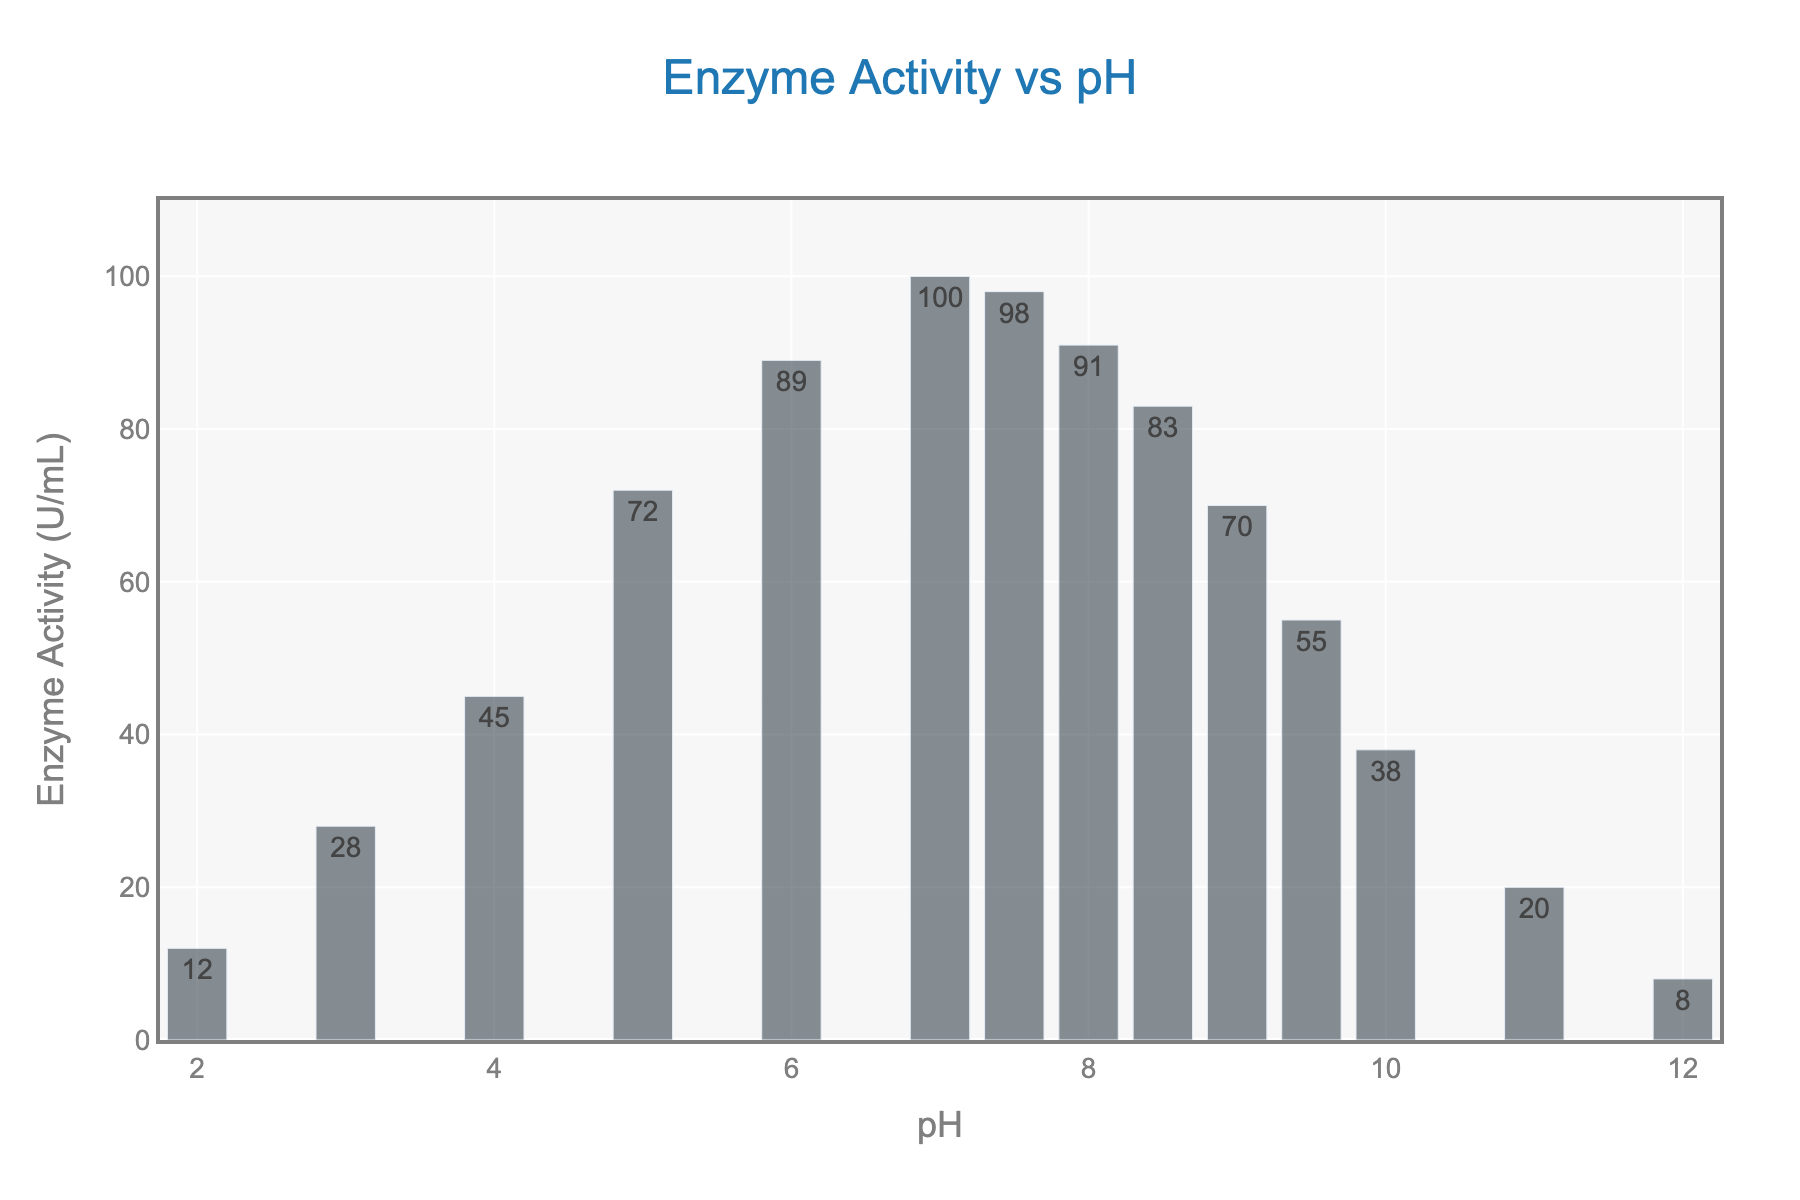What is the pH value at which enzyme activity is highest? The tallest bar in the chart represents the highest enzyme activity, which is at a pH value of 7.0.
Answer: 7.0 At which pH values does the enzyme activity exceed 90 U/mL? Reviewing the bar chart, enzyme activity exceeds 90 U/mL at pH values of 6.0, 7.0, 7.5, and 8.0.
Answer: 6.0, 7.0, 7.5, 8.0 Does enzyme activity decrease more sharply from pH 10.0 to 12.0 or from pH 5.0 to 4.0? Calculate the difference in enzyme activity between pH 10.0 (38) and pH 12.0 (8): 38 - 8 = 30. The difference in enzyme activity between pH 5.0 (72) and pH 4.0 (45) is 72 - 45 = 27. The sharper decrease is from pH 10.0 to 12.0.
Answer: pH 10.0 to 12.0 What is the average enzyme activity between pH 6.0 and 8.0? The enzyme activities at pH 6.0, 7.0, 7.5, and 8.0 are 89, 100, 98, and 91 respectively. The average is (89 + 100 + 98 + 91) / 4 = 94.5 U/mL.
Answer: 94.5 U/mL At which pH value does enzyme activity start to decrease after reaching its peak? The enzyme activity peaks at pH 7.0, so after this point, pH 7.5 shows a decrease.
Answer: 7.5 How much does the enzyme activity decrease between pH 7.0 and 11.0? The enzyme activity at pH 7.0 is 100 U/mL and at pH 11.0 is 20 U/mL. The decrease is 100 - 20 = 80 U/mL.
Answer: 80 U/mL What is the total enzyme activity across all pH levels? Sum of all enzyme activity values: 12 + 28 + 45 + 72 + 89 + 100 + 98 + 91 + 83 + 70 + 55 + 38 + 20 + 8 = 809 U/mL.
Answer: 809 U/mL Visualize the difference in height between the bars at pH 3.0 and 8.5. The enzyme activity at pH 3.0 is 28 U/mL and at pH 8.5 is 83 U/mL. 83 - 28 = 55 U/mL.
Answer: 55 U/mL 